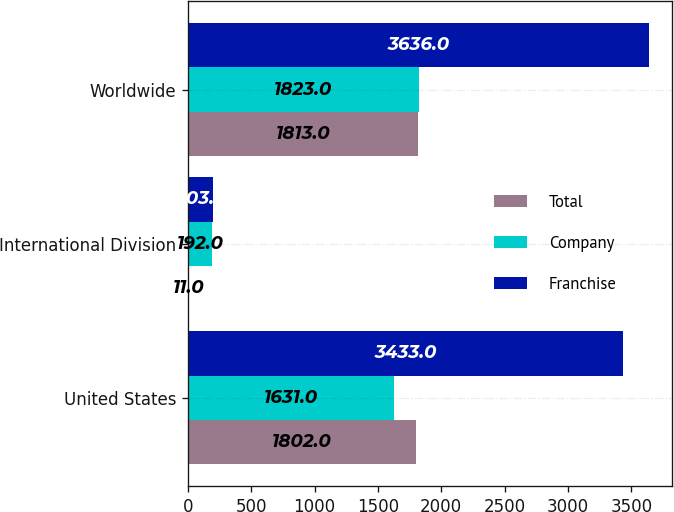Convert chart to OTSL. <chart><loc_0><loc_0><loc_500><loc_500><stacked_bar_chart><ecel><fcel>United States<fcel>International Division<fcel>Worldwide<nl><fcel>Total<fcel>1802<fcel>11<fcel>1813<nl><fcel>Company<fcel>1631<fcel>192<fcel>1823<nl><fcel>Franchise<fcel>3433<fcel>203<fcel>3636<nl></chart> 